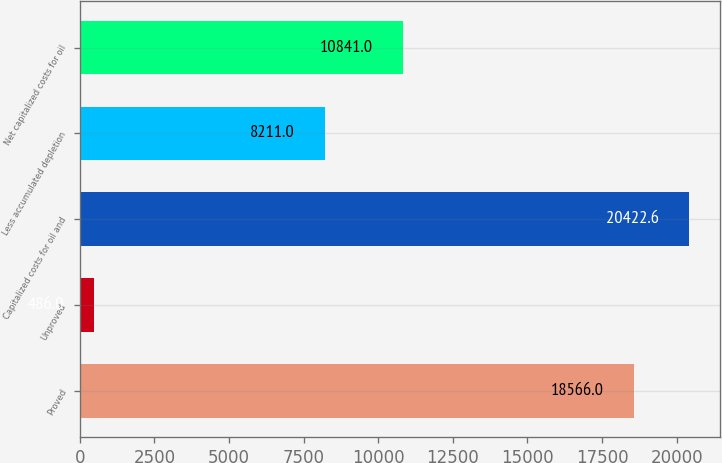Convert chart. <chart><loc_0><loc_0><loc_500><loc_500><bar_chart><fcel>Proved<fcel>Unproved<fcel>Capitalized costs for oil and<fcel>Less accumulated depletion<fcel>Net capitalized costs for oil<nl><fcel>18566<fcel>486<fcel>20422.6<fcel>8211<fcel>10841<nl></chart> 